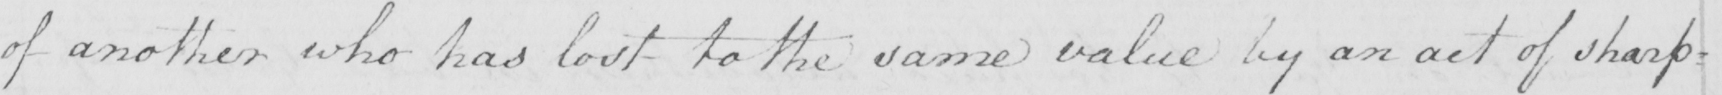What does this handwritten line say? of another who has lost to the same value by an act of sharp= 